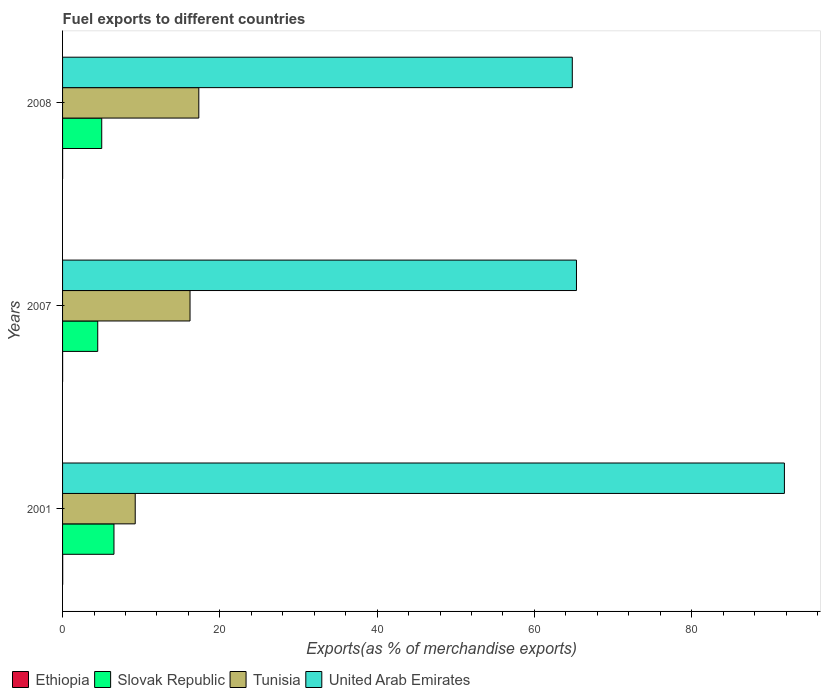How many different coloured bars are there?
Offer a very short reply. 4. Are the number of bars per tick equal to the number of legend labels?
Ensure brevity in your answer.  Yes. How many bars are there on the 2nd tick from the top?
Make the answer very short. 4. What is the label of the 1st group of bars from the top?
Your answer should be compact. 2008. What is the percentage of exports to different countries in Slovak Republic in 2001?
Give a very brief answer. 6.54. Across all years, what is the maximum percentage of exports to different countries in United Arab Emirates?
Provide a short and direct response. 91.79. Across all years, what is the minimum percentage of exports to different countries in Slovak Republic?
Offer a very short reply. 4.47. In which year was the percentage of exports to different countries in Ethiopia minimum?
Keep it short and to the point. 2008. What is the total percentage of exports to different countries in United Arab Emirates in the graph?
Keep it short and to the point. 221.95. What is the difference between the percentage of exports to different countries in Tunisia in 2001 and that in 2007?
Keep it short and to the point. -6.97. What is the difference between the percentage of exports to different countries in Tunisia in 2007 and the percentage of exports to different countries in United Arab Emirates in 2001?
Give a very brief answer. -75.58. What is the average percentage of exports to different countries in United Arab Emirates per year?
Provide a succinct answer. 73.98. In the year 2007, what is the difference between the percentage of exports to different countries in Slovak Republic and percentage of exports to different countries in Tunisia?
Offer a very short reply. -11.74. What is the ratio of the percentage of exports to different countries in Slovak Republic in 2007 to that in 2008?
Provide a succinct answer. 0.9. Is the difference between the percentage of exports to different countries in Slovak Republic in 2001 and 2008 greater than the difference between the percentage of exports to different countries in Tunisia in 2001 and 2008?
Give a very brief answer. Yes. What is the difference between the highest and the second highest percentage of exports to different countries in Slovak Republic?
Make the answer very short. 1.56. What is the difference between the highest and the lowest percentage of exports to different countries in Tunisia?
Provide a short and direct response. 8.09. In how many years, is the percentage of exports to different countries in Tunisia greater than the average percentage of exports to different countries in Tunisia taken over all years?
Offer a terse response. 2. Is it the case that in every year, the sum of the percentage of exports to different countries in Ethiopia and percentage of exports to different countries in Slovak Republic is greater than the sum of percentage of exports to different countries in United Arab Emirates and percentage of exports to different countries in Tunisia?
Give a very brief answer. No. What does the 2nd bar from the top in 2007 represents?
Offer a very short reply. Tunisia. What does the 1st bar from the bottom in 2007 represents?
Ensure brevity in your answer.  Ethiopia. How many bars are there?
Provide a succinct answer. 12. What is the difference between two consecutive major ticks on the X-axis?
Make the answer very short. 20. Are the values on the major ticks of X-axis written in scientific E-notation?
Give a very brief answer. No. Does the graph contain grids?
Provide a short and direct response. No. How many legend labels are there?
Your answer should be very brief. 4. How are the legend labels stacked?
Your answer should be very brief. Horizontal. What is the title of the graph?
Provide a succinct answer. Fuel exports to different countries. What is the label or title of the X-axis?
Provide a short and direct response. Exports(as % of merchandise exports). What is the label or title of the Y-axis?
Ensure brevity in your answer.  Years. What is the Exports(as % of merchandise exports) of Ethiopia in 2001?
Provide a short and direct response. 0.01. What is the Exports(as % of merchandise exports) of Slovak Republic in 2001?
Offer a very short reply. 6.54. What is the Exports(as % of merchandise exports) in Tunisia in 2001?
Offer a very short reply. 9.24. What is the Exports(as % of merchandise exports) in United Arab Emirates in 2001?
Keep it short and to the point. 91.79. What is the Exports(as % of merchandise exports) of Ethiopia in 2007?
Provide a short and direct response. 0.01. What is the Exports(as % of merchandise exports) of Slovak Republic in 2007?
Your response must be concise. 4.47. What is the Exports(as % of merchandise exports) in Tunisia in 2007?
Give a very brief answer. 16.21. What is the Exports(as % of merchandise exports) in United Arab Emirates in 2007?
Ensure brevity in your answer.  65.35. What is the Exports(as % of merchandise exports) of Ethiopia in 2008?
Ensure brevity in your answer.  0.01. What is the Exports(as % of merchandise exports) in Slovak Republic in 2008?
Your answer should be very brief. 4.98. What is the Exports(as % of merchandise exports) in Tunisia in 2008?
Keep it short and to the point. 17.32. What is the Exports(as % of merchandise exports) in United Arab Emirates in 2008?
Your response must be concise. 64.81. Across all years, what is the maximum Exports(as % of merchandise exports) of Ethiopia?
Ensure brevity in your answer.  0.01. Across all years, what is the maximum Exports(as % of merchandise exports) in Slovak Republic?
Your answer should be compact. 6.54. Across all years, what is the maximum Exports(as % of merchandise exports) in Tunisia?
Offer a very short reply. 17.32. Across all years, what is the maximum Exports(as % of merchandise exports) in United Arab Emirates?
Your response must be concise. 91.79. Across all years, what is the minimum Exports(as % of merchandise exports) in Ethiopia?
Your response must be concise. 0.01. Across all years, what is the minimum Exports(as % of merchandise exports) in Slovak Republic?
Your answer should be very brief. 4.47. Across all years, what is the minimum Exports(as % of merchandise exports) in Tunisia?
Offer a very short reply. 9.24. Across all years, what is the minimum Exports(as % of merchandise exports) in United Arab Emirates?
Keep it short and to the point. 64.81. What is the total Exports(as % of merchandise exports) of Ethiopia in the graph?
Provide a short and direct response. 0.03. What is the total Exports(as % of merchandise exports) in Slovak Republic in the graph?
Offer a terse response. 15.99. What is the total Exports(as % of merchandise exports) in Tunisia in the graph?
Provide a short and direct response. 42.77. What is the total Exports(as % of merchandise exports) of United Arab Emirates in the graph?
Make the answer very short. 221.95. What is the difference between the Exports(as % of merchandise exports) in Ethiopia in 2001 and that in 2007?
Ensure brevity in your answer.  0.01. What is the difference between the Exports(as % of merchandise exports) of Slovak Republic in 2001 and that in 2007?
Keep it short and to the point. 2.07. What is the difference between the Exports(as % of merchandise exports) of Tunisia in 2001 and that in 2007?
Your answer should be compact. -6.97. What is the difference between the Exports(as % of merchandise exports) of United Arab Emirates in 2001 and that in 2007?
Keep it short and to the point. 26.44. What is the difference between the Exports(as % of merchandise exports) of Ethiopia in 2001 and that in 2008?
Make the answer very short. 0.01. What is the difference between the Exports(as % of merchandise exports) in Slovak Republic in 2001 and that in 2008?
Your answer should be compact. 1.56. What is the difference between the Exports(as % of merchandise exports) in Tunisia in 2001 and that in 2008?
Keep it short and to the point. -8.09. What is the difference between the Exports(as % of merchandise exports) of United Arab Emirates in 2001 and that in 2008?
Your answer should be very brief. 26.97. What is the difference between the Exports(as % of merchandise exports) of Slovak Republic in 2007 and that in 2008?
Give a very brief answer. -0.51. What is the difference between the Exports(as % of merchandise exports) in Tunisia in 2007 and that in 2008?
Offer a terse response. -1.12. What is the difference between the Exports(as % of merchandise exports) in United Arab Emirates in 2007 and that in 2008?
Give a very brief answer. 0.53. What is the difference between the Exports(as % of merchandise exports) in Ethiopia in 2001 and the Exports(as % of merchandise exports) in Slovak Republic in 2007?
Provide a succinct answer. -4.46. What is the difference between the Exports(as % of merchandise exports) of Ethiopia in 2001 and the Exports(as % of merchandise exports) of Tunisia in 2007?
Provide a short and direct response. -16.19. What is the difference between the Exports(as % of merchandise exports) in Ethiopia in 2001 and the Exports(as % of merchandise exports) in United Arab Emirates in 2007?
Offer a very short reply. -65.33. What is the difference between the Exports(as % of merchandise exports) in Slovak Republic in 2001 and the Exports(as % of merchandise exports) in Tunisia in 2007?
Your response must be concise. -9.67. What is the difference between the Exports(as % of merchandise exports) in Slovak Republic in 2001 and the Exports(as % of merchandise exports) in United Arab Emirates in 2007?
Give a very brief answer. -58.81. What is the difference between the Exports(as % of merchandise exports) in Tunisia in 2001 and the Exports(as % of merchandise exports) in United Arab Emirates in 2007?
Your answer should be very brief. -56.11. What is the difference between the Exports(as % of merchandise exports) of Ethiopia in 2001 and the Exports(as % of merchandise exports) of Slovak Republic in 2008?
Your answer should be compact. -4.97. What is the difference between the Exports(as % of merchandise exports) in Ethiopia in 2001 and the Exports(as % of merchandise exports) in Tunisia in 2008?
Your response must be concise. -17.31. What is the difference between the Exports(as % of merchandise exports) in Ethiopia in 2001 and the Exports(as % of merchandise exports) in United Arab Emirates in 2008?
Provide a short and direct response. -64.8. What is the difference between the Exports(as % of merchandise exports) of Slovak Republic in 2001 and the Exports(as % of merchandise exports) of Tunisia in 2008?
Your answer should be very brief. -10.79. What is the difference between the Exports(as % of merchandise exports) of Slovak Republic in 2001 and the Exports(as % of merchandise exports) of United Arab Emirates in 2008?
Ensure brevity in your answer.  -58.28. What is the difference between the Exports(as % of merchandise exports) in Tunisia in 2001 and the Exports(as % of merchandise exports) in United Arab Emirates in 2008?
Keep it short and to the point. -55.58. What is the difference between the Exports(as % of merchandise exports) in Ethiopia in 2007 and the Exports(as % of merchandise exports) in Slovak Republic in 2008?
Your response must be concise. -4.97. What is the difference between the Exports(as % of merchandise exports) of Ethiopia in 2007 and the Exports(as % of merchandise exports) of Tunisia in 2008?
Provide a succinct answer. -17.32. What is the difference between the Exports(as % of merchandise exports) of Ethiopia in 2007 and the Exports(as % of merchandise exports) of United Arab Emirates in 2008?
Offer a terse response. -64.81. What is the difference between the Exports(as % of merchandise exports) of Slovak Republic in 2007 and the Exports(as % of merchandise exports) of Tunisia in 2008?
Give a very brief answer. -12.85. What is the difference between the Exports(as % of merchandise exports) in Slovak Republic in 2007 and the Exports(as % of merchandise exports) in United Arab Emirates in 2008?
Provide a short and direct response. -60.34. What is the difference between the Exports(as % of merchandise exports) of Tunisia in 2007 and the Exports(as % of merchandise exports) of United Arab Emirates in 2008?
Give a very brief answer. -48.61. What is the average Exports(as % of merchandise exports) of Ethiopia per year?
Your answer should be very brief. 0.01. What is the average Exports(as % of merchandise exports) in Slovak Republic per year?
Your response must be concise. 5.33. What is the average Exports(as % of merchandise exports) of Tunisia per year?
Ensure brevity in your answer.  14.26. What is the average Exports(as % of merchandise exports) in United Arab Emirates per year?
Ensure brevity in your answer.  73.98. In the year 2001, what is the difference between the Exports(as % of merchandise exports) in Ethiopia and Exports(as % of merchandise exports) in Slovak Republic?
Offer a terse response. -6.52. In the year 2001, what is the difference between the Exports(as % of merchandise exports) in Ethiopia and Exports(as % of merchandise exports) in Tunisia?
Provide a short and direct response. -9.22. In the year 2001, what is the difference between the Exports(as % of merchandise exports) of Ethiopia and Exports(as % of merchandise exports) of United Arab Emirates?
Provide a succinct answer. -91.77. In the year 2001, what is the difference between the Exports(as % of merchandise exports) of Slovak Republic and Exports(as % of merchandise exports) of Tunisia?
Make the answer very short. -2.7. In the year 2001, what is the difference between the Exports(as % of merchandise exports) in Slovak Republic and Exports(as % of merchandise exports) in United Arab Emirates?
Keep it short and to the point. -85.25. In the year 2001, what is the difference between the Exports(as % of merchandise exports) of Tunisia and Exports(as % of merchandise exports) of United Arab Emirates?
Offer a very short reply. -82.55. In the year 2007, what is the difference between the Exports(as % of merchandise exports) of Ethiopia and Exports(as % of merchandise exports) of Slovak Republic?
Your response must be concise. -4.47. In the year 2007, what is the difference between the Exports(as % of merchandise exports) in Ethiopia and Exports(as % of merchandise exports) in Tunisia?
Ensure brevity in your answer.  -16.2. In the year 2007, what is the difference between the Exports(as % of merchandise exports) in Ethiopia and Exports(as % of merchandise exports) in United Arab Emirates?
Your response must be concise. -65.34. In the year 2007, what is the difference between the Exports(as % of merchandise exports) in Slovak Republic and Exports(as % of merchandise exports) in Tunisia?
Provide a short and direct response. -11.74. In the year 2007, what is the difference between the Exports(as % of merchandise exports) of Slovak Republic and Exports(as % of merchandise exports) of United Arab Emirates?
Offer a terse response. -60.87. In the year 2007, what is the difference between the Exports(as % of merchandise exports) of Tunisia and Exports(as % of merchandise exports) of United Arab Emirates?
Ensure brevity in your answer.  -49.14. In the year 2008, what is the difference between the Exports(as % of merchandise exports) of Ethiopia and Exports(as % of merchandise exports) of Slovak Republic?
Ensure brevity in your answer.  -4.97. In the year 2008, what is the difference between the Exports(as % of merchandise exports) in Ethiopia and Exports(as % of merchandise exports) in Tunisia?
Offer a terse response. -17.32. In the year 2008, what is the difference between the Exports(as % of merchandise exports) in Ethiopia and Exports(as % of merchandise exports) in United Arab Emirates?
Your answer should be very brief. -64.81. In the year 2008, what is the difference between the Exports(as % of merchandise exports) in Slovak Republic and Exports(as % of merchandise exports) in Tunisia?
Offer a very short reply. -12.34. In the year 2008, what is the difference between the Exports(as % of merchandise exports) of Slovak Republic and Exports(as % of merchandise exports) of United Arab Emirates?
Make the answer very short. -59.84. In the year 2008, what is the difference between the Exports(as % of merchandise exports) of Tunisia and Exports(as % of merchandise exports) of United Arab Emirates?
Offer a terse response. -47.49. What is the ratio of the Exports(as % of merchandise exports) of Ethiopia in 2001 to that in 2007?
Make the answer very short. 2.37. What is the ratio of the Exports(as % of merchandise exports) in Slovak Republic in 2001 to that in 2007?
Offer a terse response. 1.46. What is the ratio of the Exports(as % of merchandise exports) of Tunisia in 2001 to that in 2007?
Keep it short and to the point. 0.57. What is the ratio of the Exports(as % of merchandise exports) of United Arab Emirates in 2001 to that in 2007?
Provide a short and direct response. 1.4. What is the ratio of the Exports(as % of merchandise exports) in Ethiopia in 2001 to that in 2008?
Offer a terse response. 2.84. What is the ratio of the Exports(as % of merchandise exports) of Slovak Republic in 2001 to that in 2008?
Your answer should be compact. 1.31. What is the ratio of the Exports(as % of merchandise exports) in Tunisia in 2001 to that in 2008?
Offer a very short reply. 0.53. What is the ratio of the Exports(as % of merchandise exports) of United Arab Emirates in 2001 to that in 2008?
Provide a succinct answer. 1.42. What is the ratio of the Exports(as % of merchandise exports) of Ethiopia in 2007 to that in 2008?
Offer a terse response. 1.2. What is the ratio of the Exports(as % of merchandise exports) in Slovak Republic in 2007 to that in 2008?
Provide a short and direct response. 0.9. What is the ratio of the Exports(as % of merchandise exports) in Tunisia in 2007 to that in 2008?
Keep it short and to the point. 0.94. What is the ratio of the Exports(as % of merchandise exports) in United Arab Emirates in 2007 to that in 2008?
Offer a terse response. 1.01. What is the difference between the highest and the second highest Exports(as % of merchandise exports) in Ethiopia?
Make the answer very short. 0.01. What is the difference between the highest and the second highest Exports(as % of merchandise exports) in Slovak Republic?
Offer a very short reply. 1.56. What is the difference between the highest and the second highest Exports(as % of merchandise exports) of Tunisia?
Make the answer very short. 1.12. What is the difference between the highest and the second highest Exports(as % of merchandise exports) of United Arab Emirates?
Your response must be concise. 26.44. What is the difference between the highest and the lowest Exports(as % of merchandise exports) of Ethiopia?
Your response must be concise. 0.01. What is the difference between the highest and the lowest Exports(as % of merchandise exports) of Slovak Republic?
Make the answer very short. 2.07. What is the difference between the highest and the lowest Exports(as % of merchandise exports) in Tunisia?
Offer a very short reply. 8.09. What is the difference between the highest and the lowest Exports(as % of merchandise exports) of United Arab Emirates?
Offer a very short reply. 26.97. 